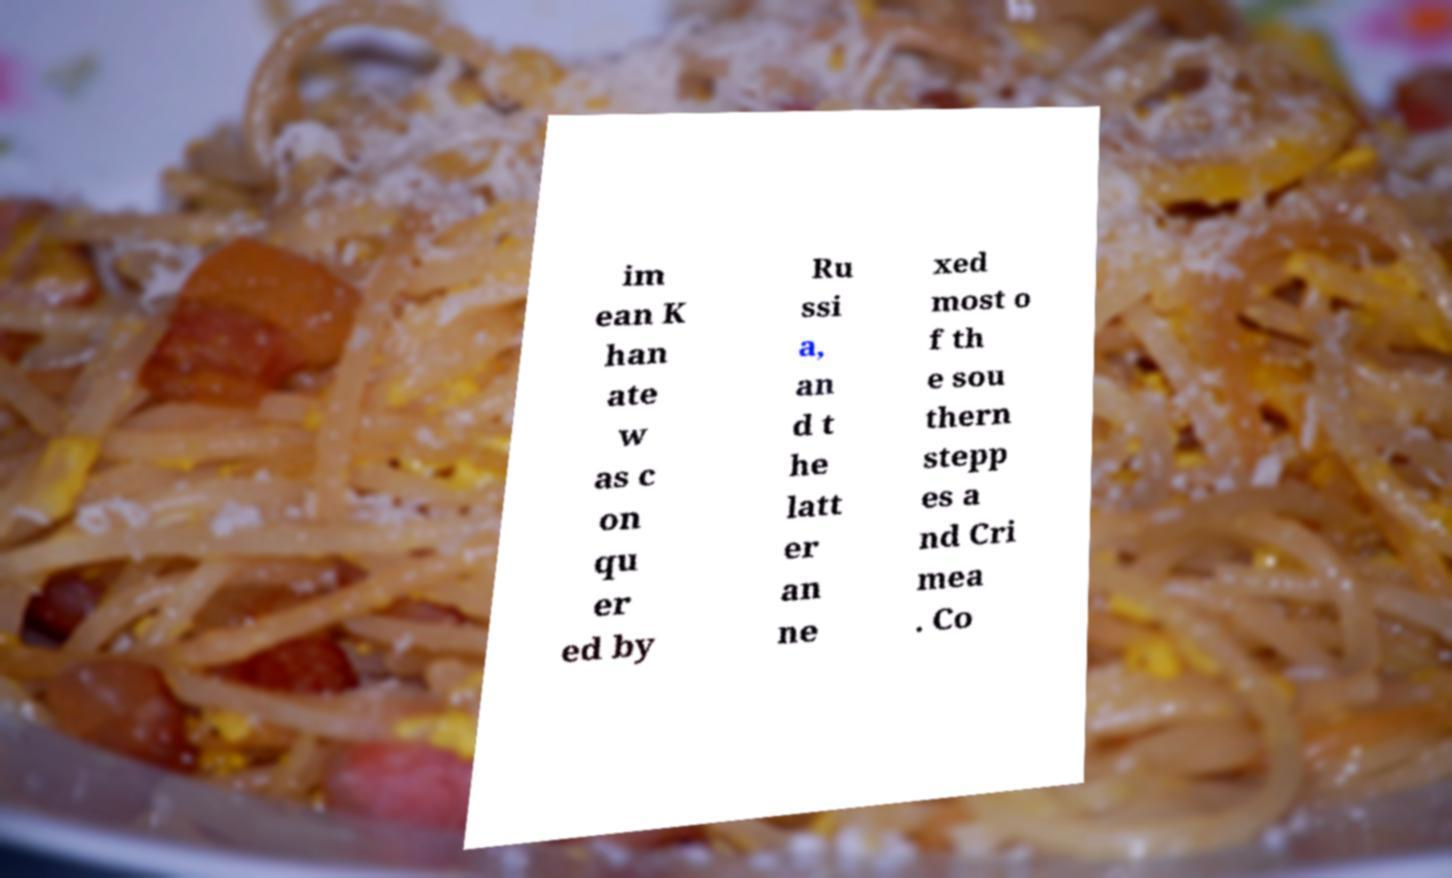Can you accurately transcribe the text from the provided image for me? im ean K han ate w as c on qu er ed by Ru ssi a, an d t he latt er an ne xed most o f th e sou thern stepp es a nd Cri mea . Co 